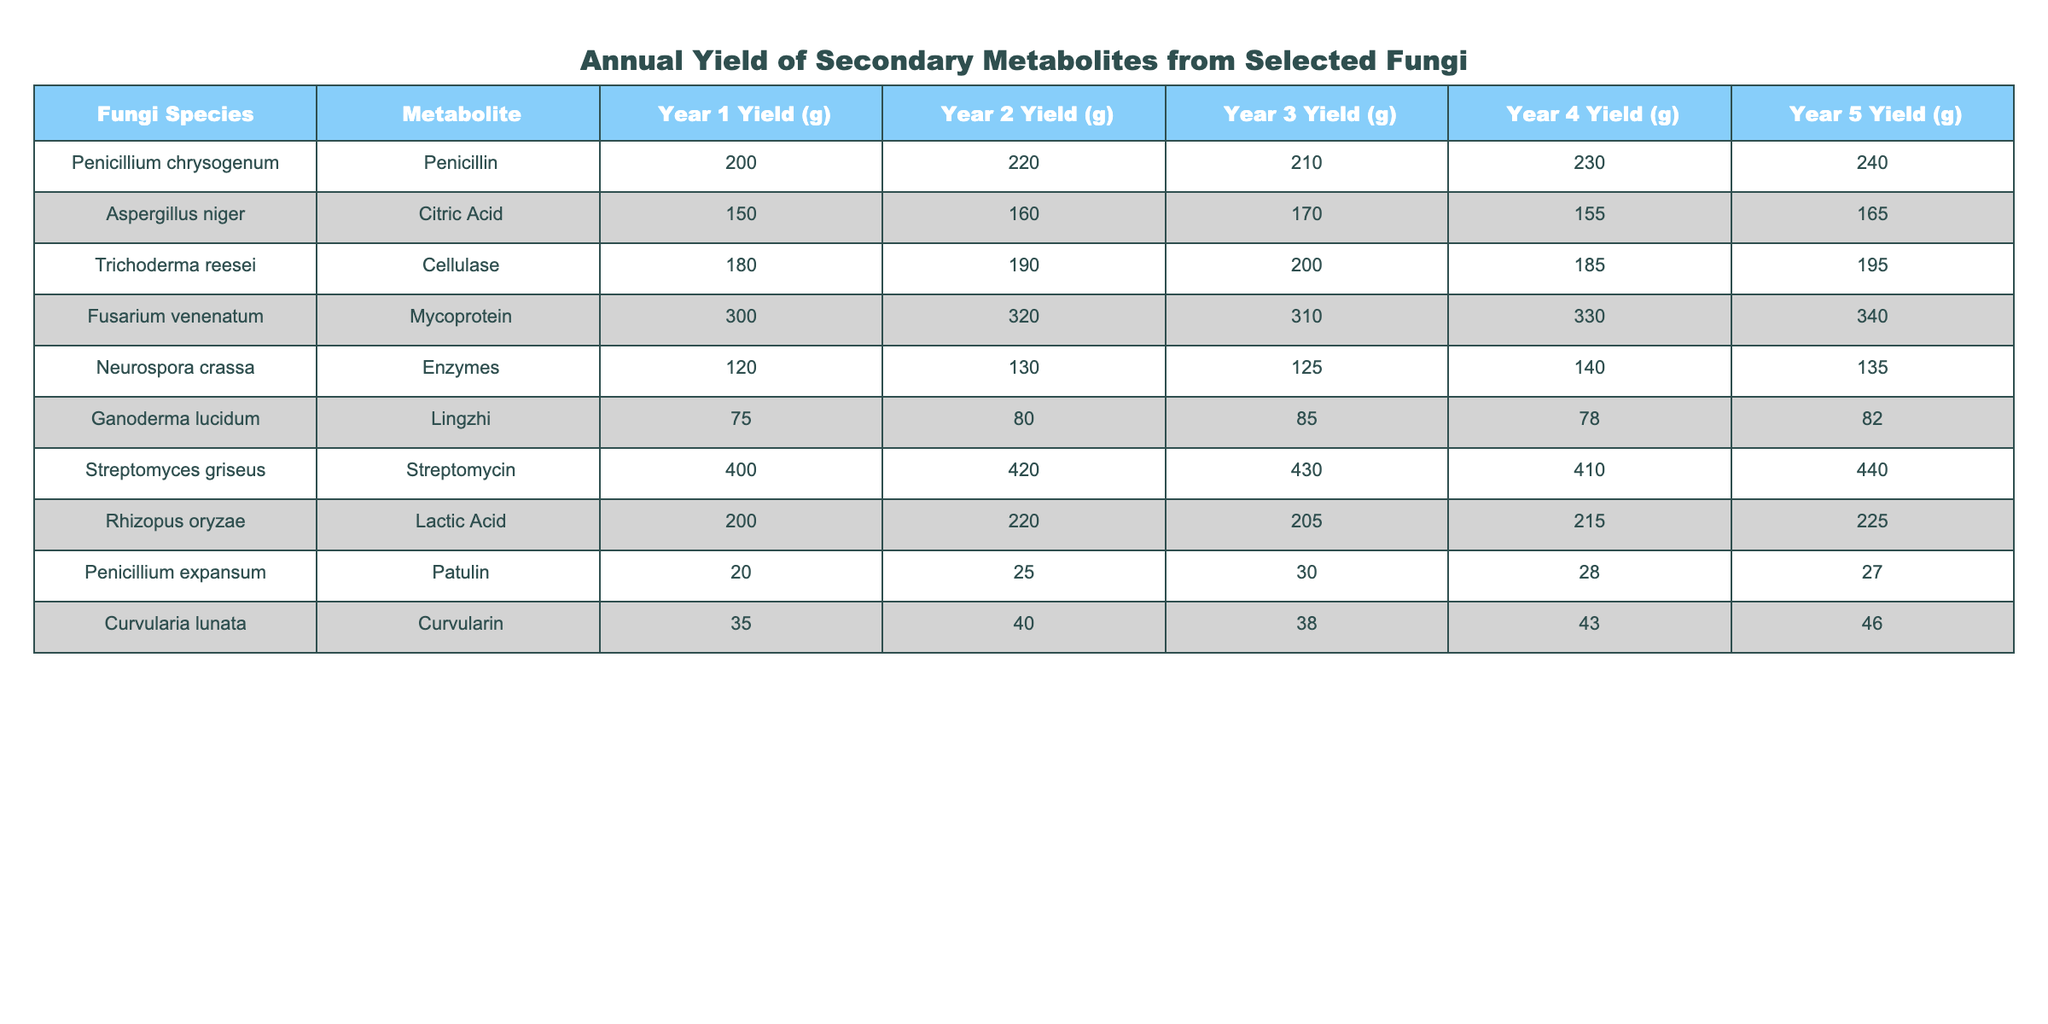What's the metabolite yield of Penicillium chrysogenum in Year 3? In the table, the yield for Penicillium chrysogenum in Year 3 is directly mentioned as 210 grams.
Answer: 210 grams What is the total yield of Mycoprotein from Fusarium venenatum over five years? To find the total yield, sum the yields for all five years: 300 + 320 + 310 + 330 + 340 = 1600 grams.
Answer: 1600 grams Which fungus produced the highest amount of metabolite in Year 4? In Year 4, the yields of each fungus are listed. The highest yield is 440 grams from Streptomyces griseus.
Answer: Streptomyces griseus Is the yield of Citric Acid from Aspergillus niger in Year 5 greater than 170 grams? In Year 5, the yield of Citric Acid from Aspergillus niger is 165 grams, which is less than 170 grams.
Answer: No What is the average annual yield of Cellulase from Trichoderma reesei over the five years? First, sum the yearly yields: 180 + 190 + 200 + 185 + 195 = 1040 grams. Then, divide by 5 years: 1040 / 5 = 208 grams.
Answer: 208 grams How did the yield of Patulin from Penicillium expansum change from Year 1 to Year 2? The yield of Patulin in Year 1 is 20 grams and in Year 2 is 25 grams. The change is 25 - 20 = 5 grams, indicating an increase.
Answer: Increased by 5 grams Which fungi had a consistent yield pattern across all years? By examining the table, no single fungus consistently increased or stayed the same; however, Ganoderma lucidum’s yield fluctuated slightly, with values only differing by a few grams each year.
Answer: None had a completely consistent pattern Calculate the difference in yield between the maximum and minimum yields from any single fungus over the five years. The highest yield is from Streptomyces griseus at 440 grams (Year 5), and the lowest is from Penicillium expansum at 20 grams (Year 1). The difference is 440 - 20 = 420 grams.
Answer: 420 grams Which fungus had the most significant increase in yield from Year 1 to Year 5? To find the most significant increase, compare Year 1 and Year 5 yields for each fungus. Fusarium venenatum's yield increased by 40 grams (300 to 340), while Streptomyces griseus’s increased by 40 grams (400 to 440). Both had the same increase, but Fusarium’s absolute yield was initially lower.
Answer: Fusarium venenatum and Streptomyces griseus both increased by 40 grams If you combine the years 2 and 4 yields of Lactic Acid from Rhizopus oryzae, what is the total? The Year 2 yield is 220 grams and Year 4 yield is 215 grams. Adding these gives 220 + 215 = 435 grams.
Answer: 435 grams 